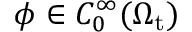Convert formula to latex. <formula><loc_0><loc_0><loc_500><loc_500>\phi \in C _ { 0 } ^ { \infty } ( \Omega _ { t } )</formula> 